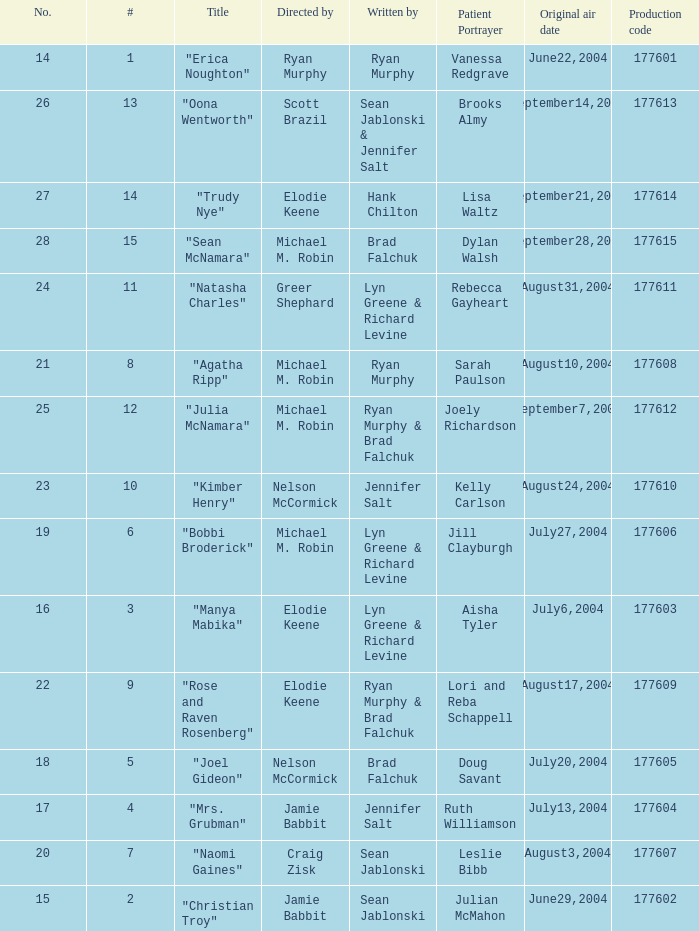Who wrote episode number 28? Brad Falchuk. 